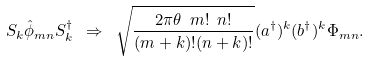Convert formula to latex. <formula><loc_0><loc_0><loc_500><loc_500>S _ { k } { \hat { \phi } } _ { m n } S _ { k } ^ { \dagger } \ \Rightarrow \ \sqrt { \frac { 2 \pi \theta \ m ! \ n ! } { ( m + k ) ! ( n + k ) ! } } ( { a ^ { \dagger } } ) ^ { k } ( { b ^ { \dagger } } ) ^ { k } \Phi _ { m n } .</formula> 